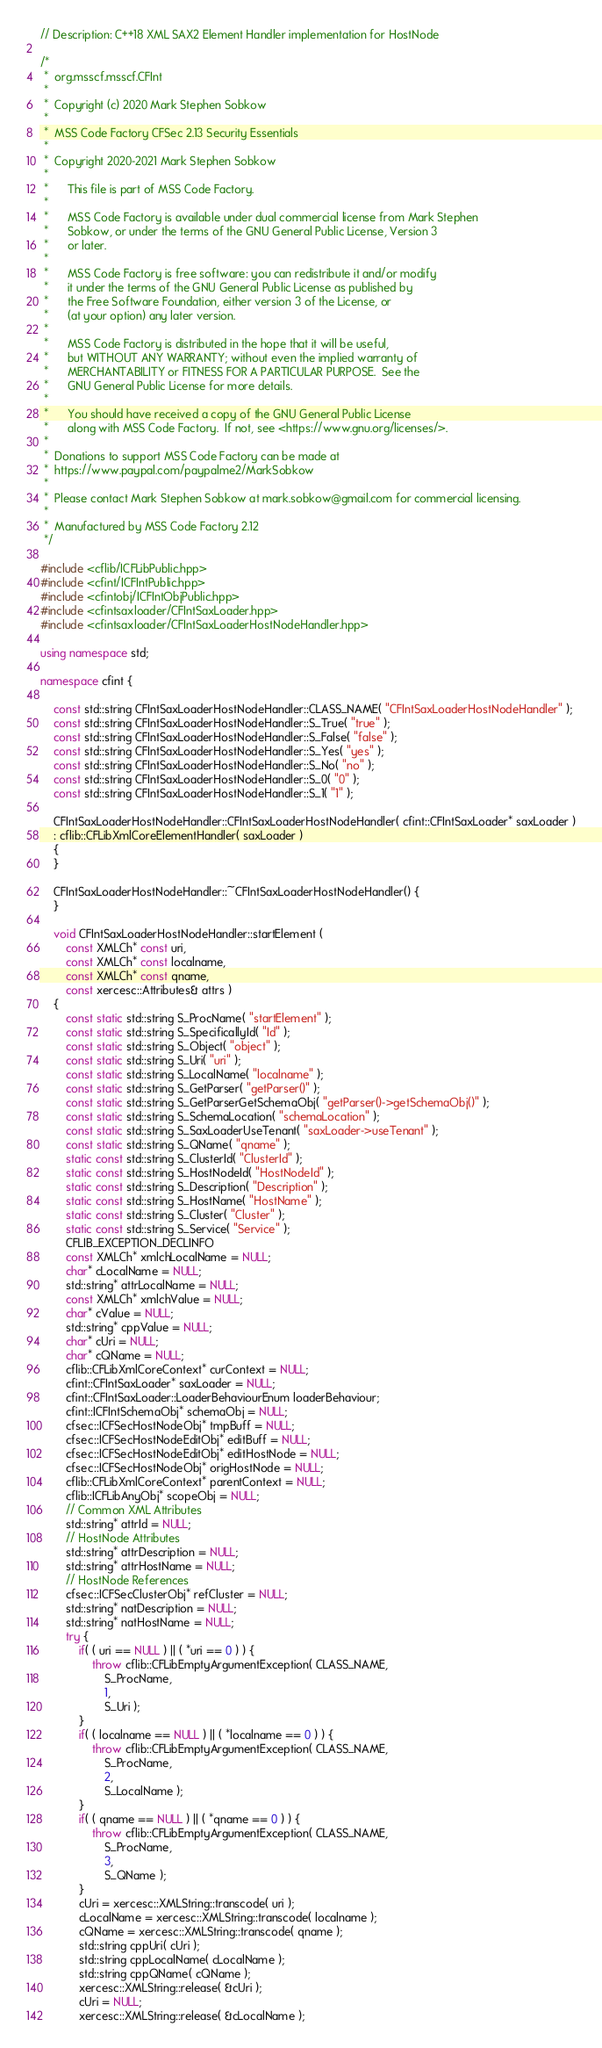<code> <loc_0><loc_0><loc_500><loc_500><_C++_>
// Description: C++18 XML SAX2 Element Handler implementation for HostNode

/*
 *	org.msscf.msscf.CFInt
 *
 *	Copyright (c) 2020 Mark Stephen Sobkow
 *	
 *	MSS Code Factory CFSec 2.13 Security Essentials
 *	
 *	Copyright 2020-2021 Mark Stephen Sobkow
 *	
 *		This file is part of MSS Code Factory.
 *	
 *		MSS Code Factory is available under dual commercial license from Mark Stephen
 *		Sobkow, or under the terms of the GNU General Public License, Version 3
 *		or later.
 *	
 *	    MSS Code Factory is free software: you can redistribute it and/or modify
 *	    it under the terms of the GNU General Public License as published by
 *	    the Free Software Foundation, either version 3 of the License, or
 *	    (at your option) any later version.
 *	
 *	    MSS Code Factory is distributed in the hope that it will be useful,
 *	    but WITHOUT ANY WARRANTY; without even the implied warranty of
 *	    MERCHANTABILITY or FITNESS FOR A PARTICULAR PURPOSE.  See the
 *	    GNU General Public License for more details.
 *	
 *	    You should have received a copy of the GNU General Public License
 *	    along with MSS Code Factory.  If not, see <https://www.gnu.org/licenses/>.
 *	
 *	Donations to support MSS Code Factory can be made at
 *	https://www.paypal.com/paypalme2/MarkSobkow
 *	
 *	Please contact Mark Stephen Sobkow at mark.sobkow@gmail.com for commercial licensing.
 *
 *	Manufactured by MSS Code Factory 2.12
 */

#include <cflib/ICFLibPublic.hpp>
#include <cfint/ICFIntPublic.hpp>
#include <cfintobj/ICFIntObjPublic.hpp>
#include <cfintsaxloader/CFIntSaxLoader.hpp>
#include <cfintsaxloader/CFIntSaxLoaderHostNodeHandler.hpp>

using namespace std;

namespace cfint {

	const std::string CFIntSaxLoaderHostNodeHandler::CLASS_NAME( "CFIntSaxLoaderHostNodeHandler" );
	const std::string CFIntSaxLoaderHostNodeHandler::S_True( "true" );
	const std::string CFIntSaxLoaderHostNodeHandler::S_False( "false" );
	const std::string CFIntSaxLoaderHostNodeHandler::S_Yes( "yes" );
	const std::string CFIntSaxLoaderHostNodeHandler::S_No( "no" );
	const std::string CFIntSaxLoaderHostNodeHandler::S_0( "0" );
	const std::string CFIntSaxLoaderHostNodeHandler::S_1( "1" );

	CFIntSaxLoaderHostNodeHandler::CFIntSaxLoaderHostNodeHandler( cfint::CFIntSaxLoader* saxLoader )
	: cflib::CFLibXmlCoreElementHandler( saxLoader )
	{
	}

	CFIntSaxLoaderHostNodeHandler::~CFIntSaxLoaderHostNodeHandler() {
	}

	void CFIntSaxLoaderHostNodeHandler::startElement (
		const XMLCh* const uri,
		const XMLCh* const localname,
		const XMLCh* const qname,
		const xercesc::Attributes& attrs )
	{
		const static std::string S_ProcName( "startElement" );
		const static std::string S_SpecificallyId( "Id" );
		const static std::string S_Object( "object" );
		const static std::string S_Uri( "uri" );
		const static std::string S_LocalName( "localname" );
		const static std::string S_GetParser( "getParser()" );
		const static std::string S_GetParserGetSchemaObj( "getParser()->getSchemaObj()" );
		const static std::string S_SchemaLocation( "schemaLocation" );
		const static std::string S_SaxLoaderUseTenant( "saxLoader->useTenant" );
		const static std::string S_QName( "qname" );
		static const std::string S_ClusterId( "ClusterId" );
		static const std::string S_HostNodeId( "HostNodeId" );
		static const std::string S_Description( "Description" );
		static const std::string S_HostName( "HostName" );
		static const std::string S_Cluster( "Cluster" );
		static const std::string S_Service( "Service" );
		CFLIB_EXCEPTION_DECLINFO
		const XMLCh* xmlchLocalName = NULL;
		char* cLocalName = NULL;
		std::string* attrLocalName = NULL;
		const XMLCh* xmlchValue = NULL;
		char* cValue = NULL;
		std::string* cppValue = NULL;
		char* cUri = NULL;
		char* cQName = NULL;
		cflib::CFLibXmlCoreContext* curContext = NULL;
		cfint::CFIntSaxLoader* saxLoader = NULL;
		cfint::CFIntSaxLoader::LoaderBehaviourEnum loaderBehaviour;
		cfint::ICFIntSchemaObj* schemaObj = NULL;
		cfsec::ICFSecHostNodeObj* tmpBuff = NULL;
		cfsec::ICFSecHostNodeEditObj* editBuff = NULL;
		cfsec::ICFSecHostNodeEditObj* editHostNode = NULL;
		cfsec::ICFSecHostNodeObj* origHostNode = NULL;
		cflib::CFLibXmlCoreContext* parentContext = NULL;
		cflib::ICFLibAnyObj* scopeObj = NULL;
		// Common XML Attributes
		std::string* attrId = NULL;
		// HostNode Attributes
		std::string* attrDescription = NULL;
		std::string* attrHostName = NULL;
		// HostNode References
		cfsec::ICFSecClusterObj* refCluster = NULL;
		std::string* natDescription = NULL;
		std::string* natHostName = NULL;
		try {
			if( ( uri == NULL ) || ( *uri == 0 ) ) {
				throw cflib::CFLibEmptyArgumentException( CLASS_NAME,
					S_ProcName,
					1,
					S_Uri );
			}
			if( ( localname == NULL ) || ( *localname == 0 ) ) {
				throw cflib::CFLibEmptyArgumentException( CLASS_NAME,
					S_ProcName,
					2,
					S_LocalName );
			}
			if( ( qname == NULL ) || ( *qname == 0 ) ) {
				throw cflib::CFLibEmptyArgumentException( CLASS_NAME,
					S_ProcName,
					3,
					S_QName );
			}
			cUri = xercesc::XMLString::transcode( uri );
			cLocalName = xercesc::XMLString::transcode( localname );
			cQName = xercesc::XMLString::transcode( qname );
			std::string cppUri( cUri );
			std::string cppLocalName( cLocalName );
			std::string cppQName( cQName );
			xercesc::XMLString::release( &cUri );
			cUri = NULL;
			xercesc::XMLString::release( &cLocalName );</code> 